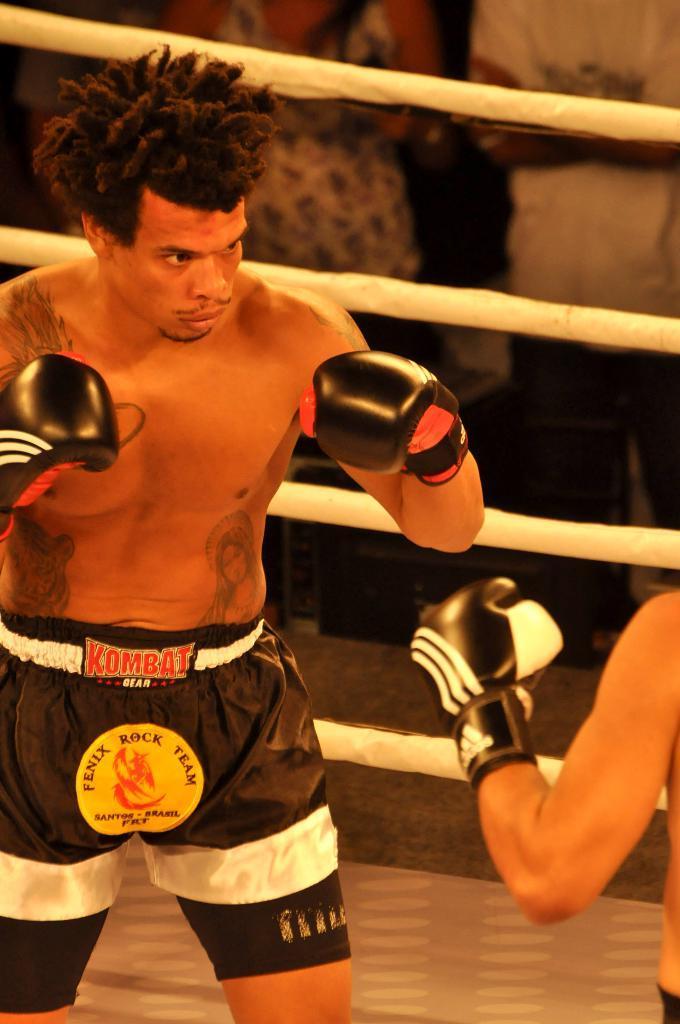Please provide a concise description of this image. In this picture we can see two men are standing and doing boxing. In the background of the image we can see the ropes and some people are standing. At the bottom of the image we can see the floor. 